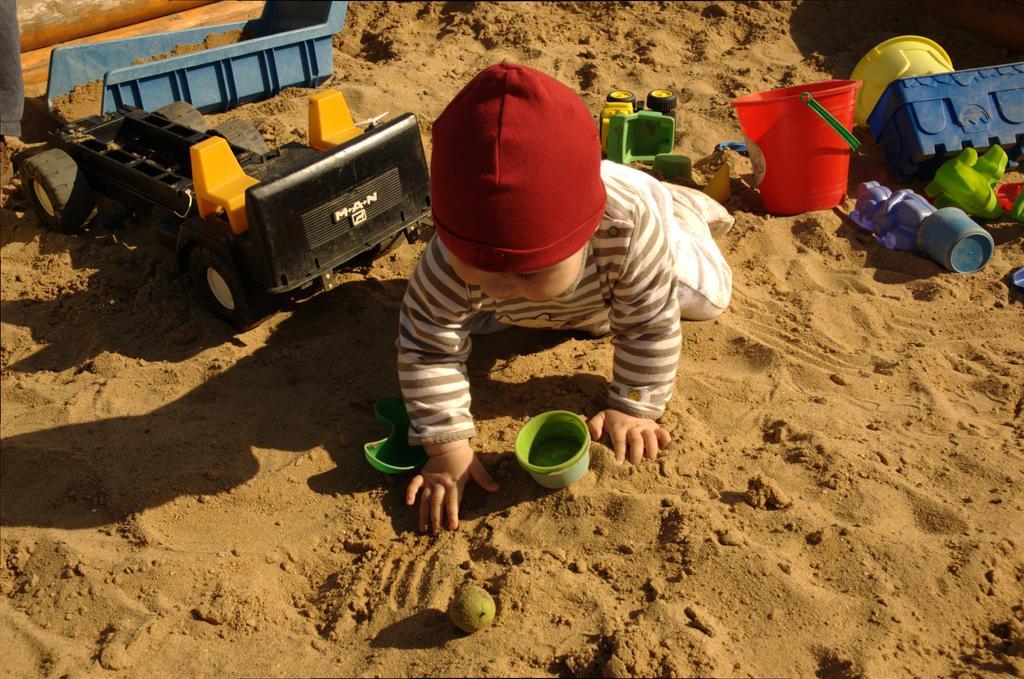Describe this image in one or two sentences. In this image I can see there is a person playing on the sand. And at the background there are some toys. 